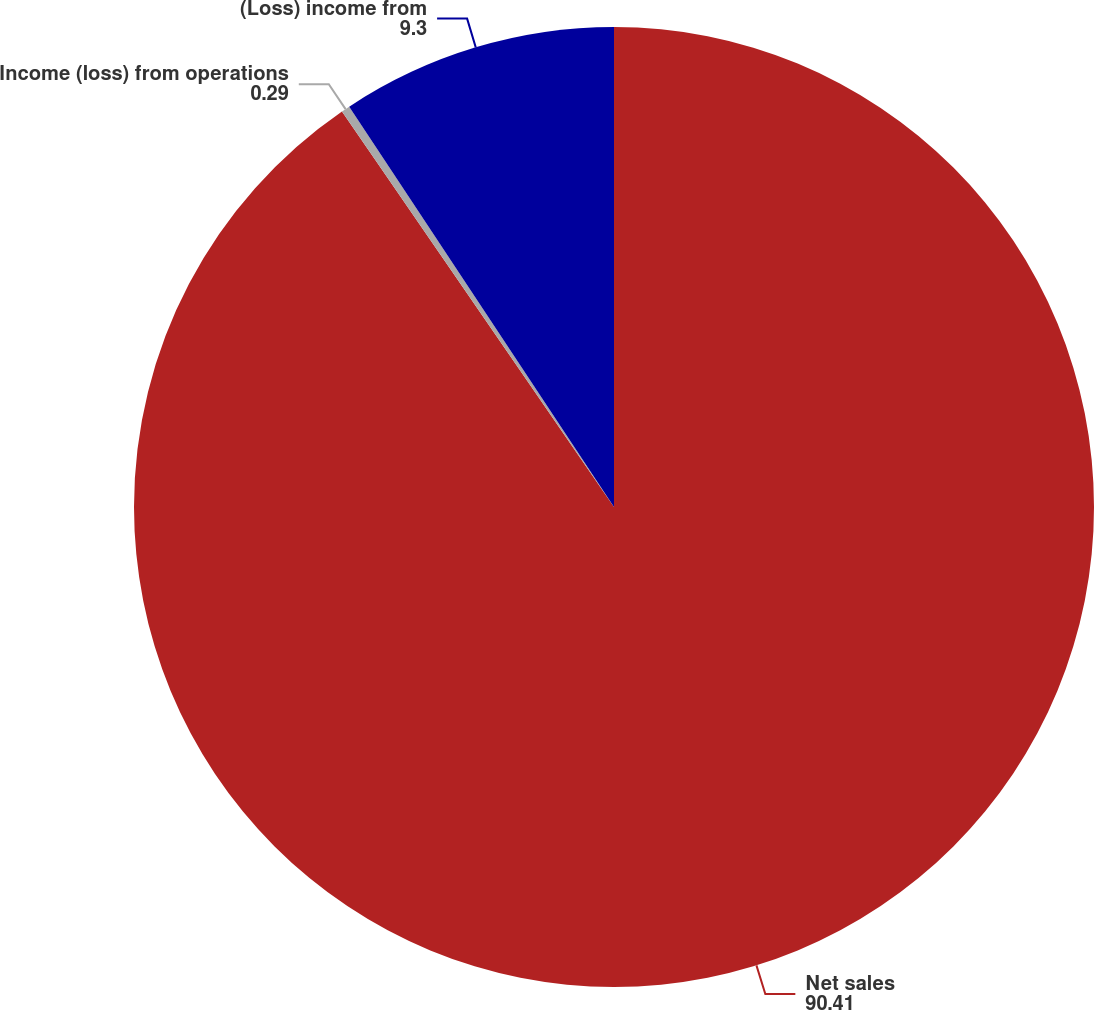<chart> <loc_0><loc_0><loc_500><loc_500><pie_chart><fcel>Net sales<fcel>Income (loss) from operations<fcel>(Loss) income from<nl><fcel>90.41%<fcel>0.29%<fcel>9.3%<nl></chart> 